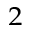<formula> <loc_0><loc_0><loc_500><loc_500>^ { 2 }</formula> 